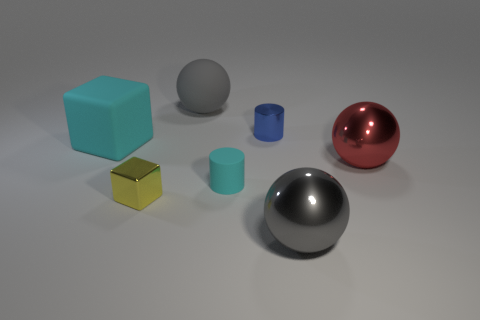Are there fewer yellow shiny cubes to the right of the small cyan rubber cylinder than shiny spheres left of the yellow block?
Ensure brevity in your answer.  No. Is the size of the gray metal ball the same as the cyan matte thing to the right of the yellow block?
Give a very brief answer. No. How many red shiny balls are the same size as the rubber sphere?
Provide a succinct answer. 1. What number of large things are cyan matte things or cyan rubber blocks?
Provide a short and direct response. 1. Is there a small yellow rubber thing?
Your answer should be compact. No. Are there more tiny matte things that are in front of the gray metal sphere than large gray matte balls that are left of the rubber cube?
Provide a short and direct response. No. The rubber thing to the right of the big object behind the large block is what color?
Your response must be concise. Cyan. Are there any other large balls that have the same color as the big rubber sphere?
Ensure brevity in your answer.  Yes. There is a cyan thing that is on the right side of the cyan matte object to the left of the gray ball that is on the left side of the rubber cylinder; what size is it?
Ensure brevity in your answer.  Small. What is the shape of the large red object?
Ensure brevity in your answer.  Sphere. 